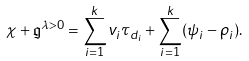<formula> <loc_0><loc_0><loc_500><loc_500>\chi + \mathfrak { g } ^ { \lambda > 0 } = \sum _ { i = 1 } ^ { k } v _ { i } \tau _ { d _ { i } } + \sum _ { i = 1 } ^ { k } ( \psi _ { i } - \rho _ { i } ) .</formula> 